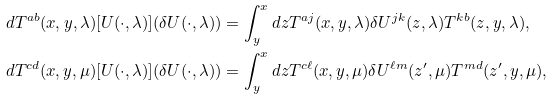Convert formula to latex. <formula><loc_0><loc_0><loc_500><loc_500>d T ^ { a b } ( x , y , \lambda ) [ U ( \cdot , \lambda ) ] ( \delta U ( \cdot , \lambda ) ) & = \int _ { y } ^ { x } d z T ^ { a j } ( x , y , \lambda ) \delta U ^ { j k } ( z , \lambda ) T ^ { k b } ( z , y , \lambda ) , \\ d T ^ { c d } ( x , y , \mu ) [ U ( \cdot , \lambda ) ] ( \delta U ( \cdot , \lambda ) ) & = \int _ { y } ^ { x } d z T ^ { c \ell } ( x , y , \mu ) \delta U ^ { \ell m } ( z ^ { \prime } , \mu ) T ^ { m d } ( z ^ { \prime } , y , \mu ) ,</formula> 